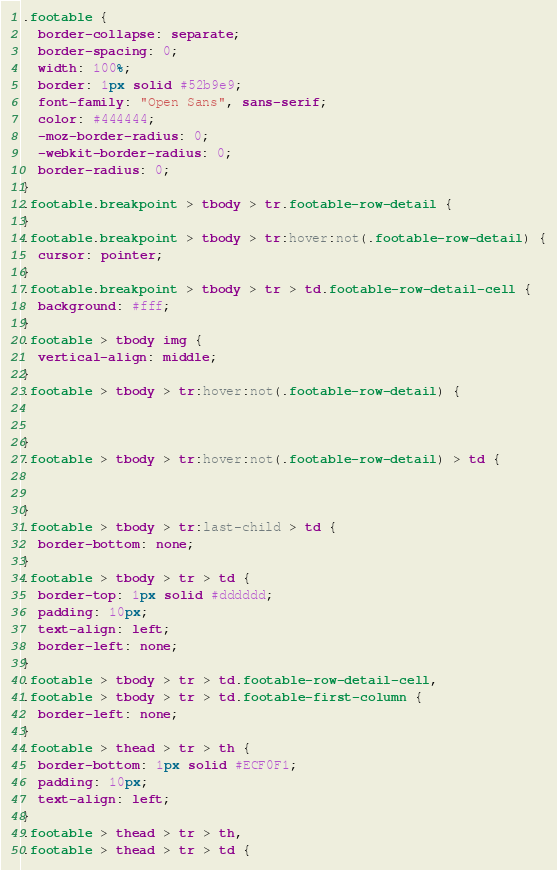Convert code to text. <code><loc_0><loc_0><loc_500><loc_500><_CSS_>.footable {
  border-collapse: separate;
  border-spacing: 0;
  width: 100%;
  border: 1px solid #52b9e9;
  font-family: "Open Sans", sans-serif;
  color: #444444;
  -moz-border-radius: 0;
  -webkit-border-radius: 0;
  border-radius: 0;
}
.footable.breakpoint > tbody > tr.footable-row-detail {
}
.footable.breakpoint > tbody > tr:hover:not(.footable-row-detail) {
  cursor: pointer;
}
.footable.breakpoint > tbody > tr > td.footable-row-detail-cell {
  background: #fff;
}
.footable > tbody img {
  vertical-align: middle;
}
.footable > tbody > tr:hover:not(.footable-row-detail) {


}
.footable > tbody > tr:hover:not(.footable-row-detail) > td {


}
.footable > tbody > tr:last-child > td {
  border-bottom: none;
}
.footable > tbody > tr > td {
  border-top: 1px solid #dddddd;
  padding: 10px;
  text-align: left;
  border-left: none;
}
.footable > tbody > tr > td.footable-row-detail-cell,
.footable > tbody > tr > td.footable-first-column {
  border-left: none;
}
.footable > thead > tr > th {
  border-bottom: 1px solid #ECF0F1;
  padding: 10px;
  text-align: left;
}
.footable > thead > tr > th,
.footable > thead > tr > td {
</code> 